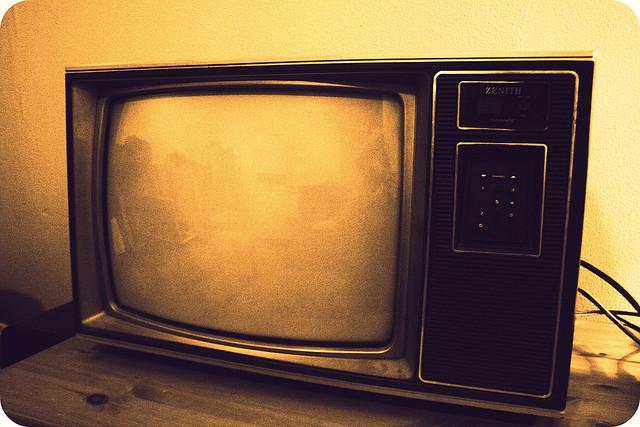What is the brand name of the television?
Short answer required. Zenith. Is the TV old?
Write a very short answer. Yes. Placed in a movie scene about modern space voyages, would this item be an anachronism?
Short answer required. Yes. 